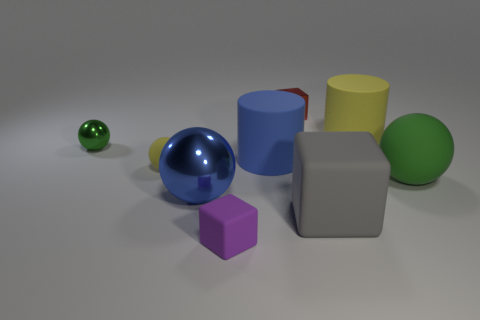There is a rubber cylinder that is the same color as the small matte sphere; what is its size?
Provide a short and direct response. Large. Do the small rubber block and the small metal ball have the same color?
Offer a terse response. No. Is there a big rubber block that has the same color as the small matte block?
Your answer should be compact. No. There is a sphere that is the same size as the green matte object; what is its color?
Your answer should be compact. Blue. Are there any brown things that have the same shape as the tiny red object?
Your response must be concise. No. There is a rubber object that is the same color as the small shiny sphere; what is its shape?
Your answer should be compact. Sphere. Is there a small green metallic sphere that is to the left of the green ball that is on the left side of the small cube that is in front of the tiny rubber sphere?
Make the answer very short. No. There is a yellow rubber object that is the same size as the gray object; what is its shape?
Your response must be concise. Cylinder. There is another metal object that is the same shape as the blue metallic object; what is its color?
Your answer should be compact. Green. How many objects are either red objects or green matte cubes?
Your response must be concise. 1. 